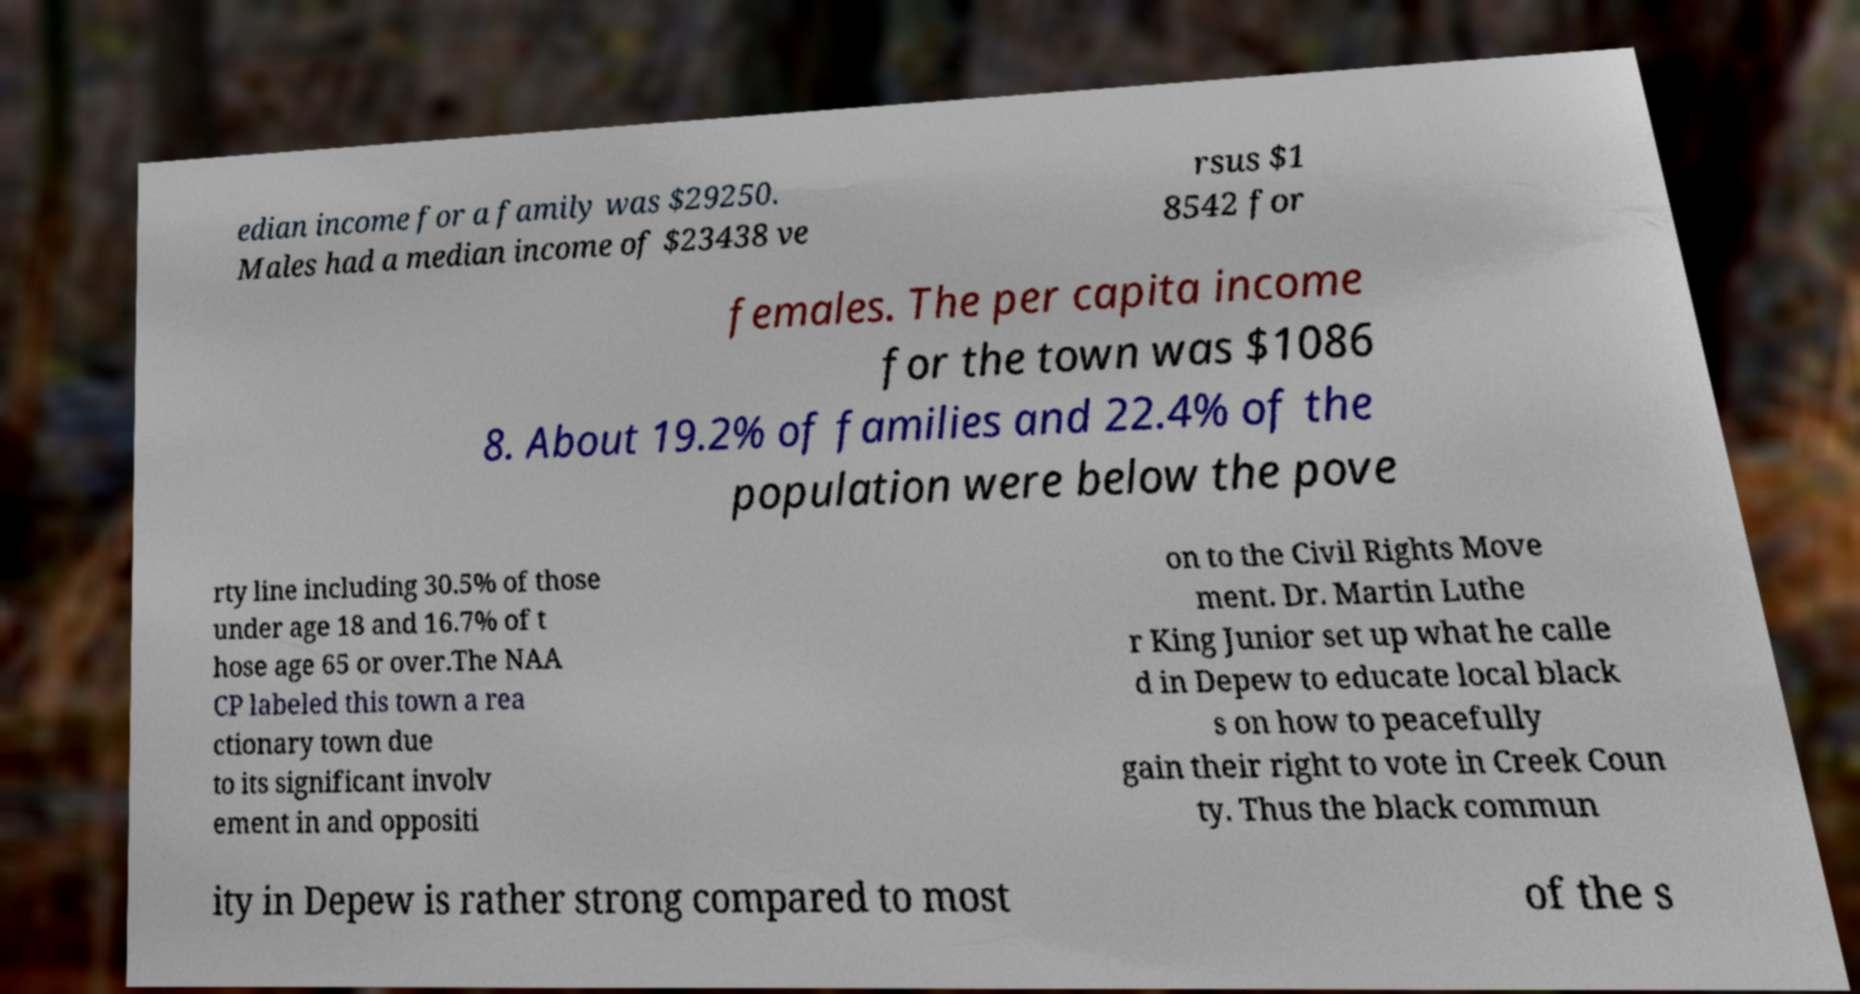Can you read and provide the text displayed in the image?This photo seems to have some interesting text. Can you extract and type it out for me? edian income for a family was $29250. Males had a median income of $23438 ve rsus $1 8542 for females. The per capita income for the town was $1086 8. About 19.2% of families and 22.4% of the population were below the pove rty line including 30.5% of those under age 18 and 16.7% of t hose age 65 or over.The NAA CP labeled this town a rea ctionary town due to its significant involv ement in and oppositi on to the Civil Rights Move ment. Dr. Martin Luthe r King Junior set up what he calle d in Depew to educate local black s on how to peacefully gain their right to vote in Creek Coun ty. Thus the black commun ity in Depew is rather strong compared to most of the s 